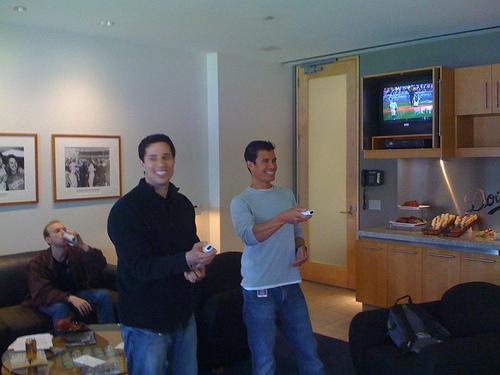What room is this?
Be succinct. Living room. Is anyone watching the baseball game?
Quick response, please. No. Is that a flat screen television?
Give a very brief answer. No. Are both players men?
Write a very short answer. Yes. How many people are on the couch?
Concise answer only. 1. Are they all looking at the camera?
Keep it brief. No. Are there chairs around?
Give a very brief answer. Yes. What pattern is on the man's shirt in the background?
Write a very short answer. Solid. If this were an actual game, who would be in the stadium?
Short answer required. Baseball players. 